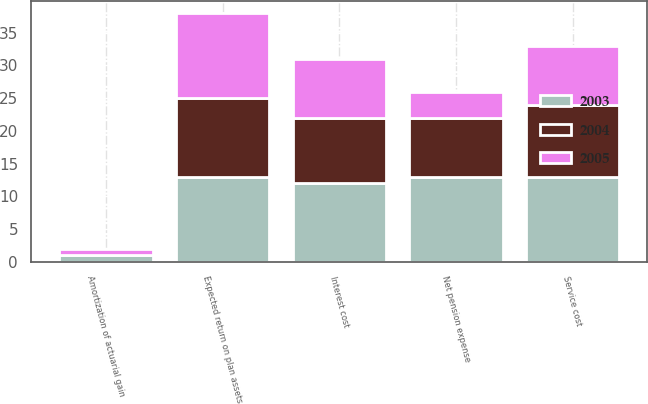<chart> <loc_0><loc_0><loc_500><loc_500><stacked_bar_chart><ecel><fcel>Service cost<fcel>Interest cost<fcel>Expected return on plan assets<fcel>Amortization of actuarial gain<fcel>Net pension expense<nl><fcel>2003<fcel>13<fcel>12<fcel>13<fcel>1<fcel>13<nl><fcel>2004<fcel>11<fcel>10<fcel>12<fcel>0<fcel>9<nl><fcel>2005<fcel>9<fcel>9<fcel>13<fcel>1<fcel>4<nl></chart> 